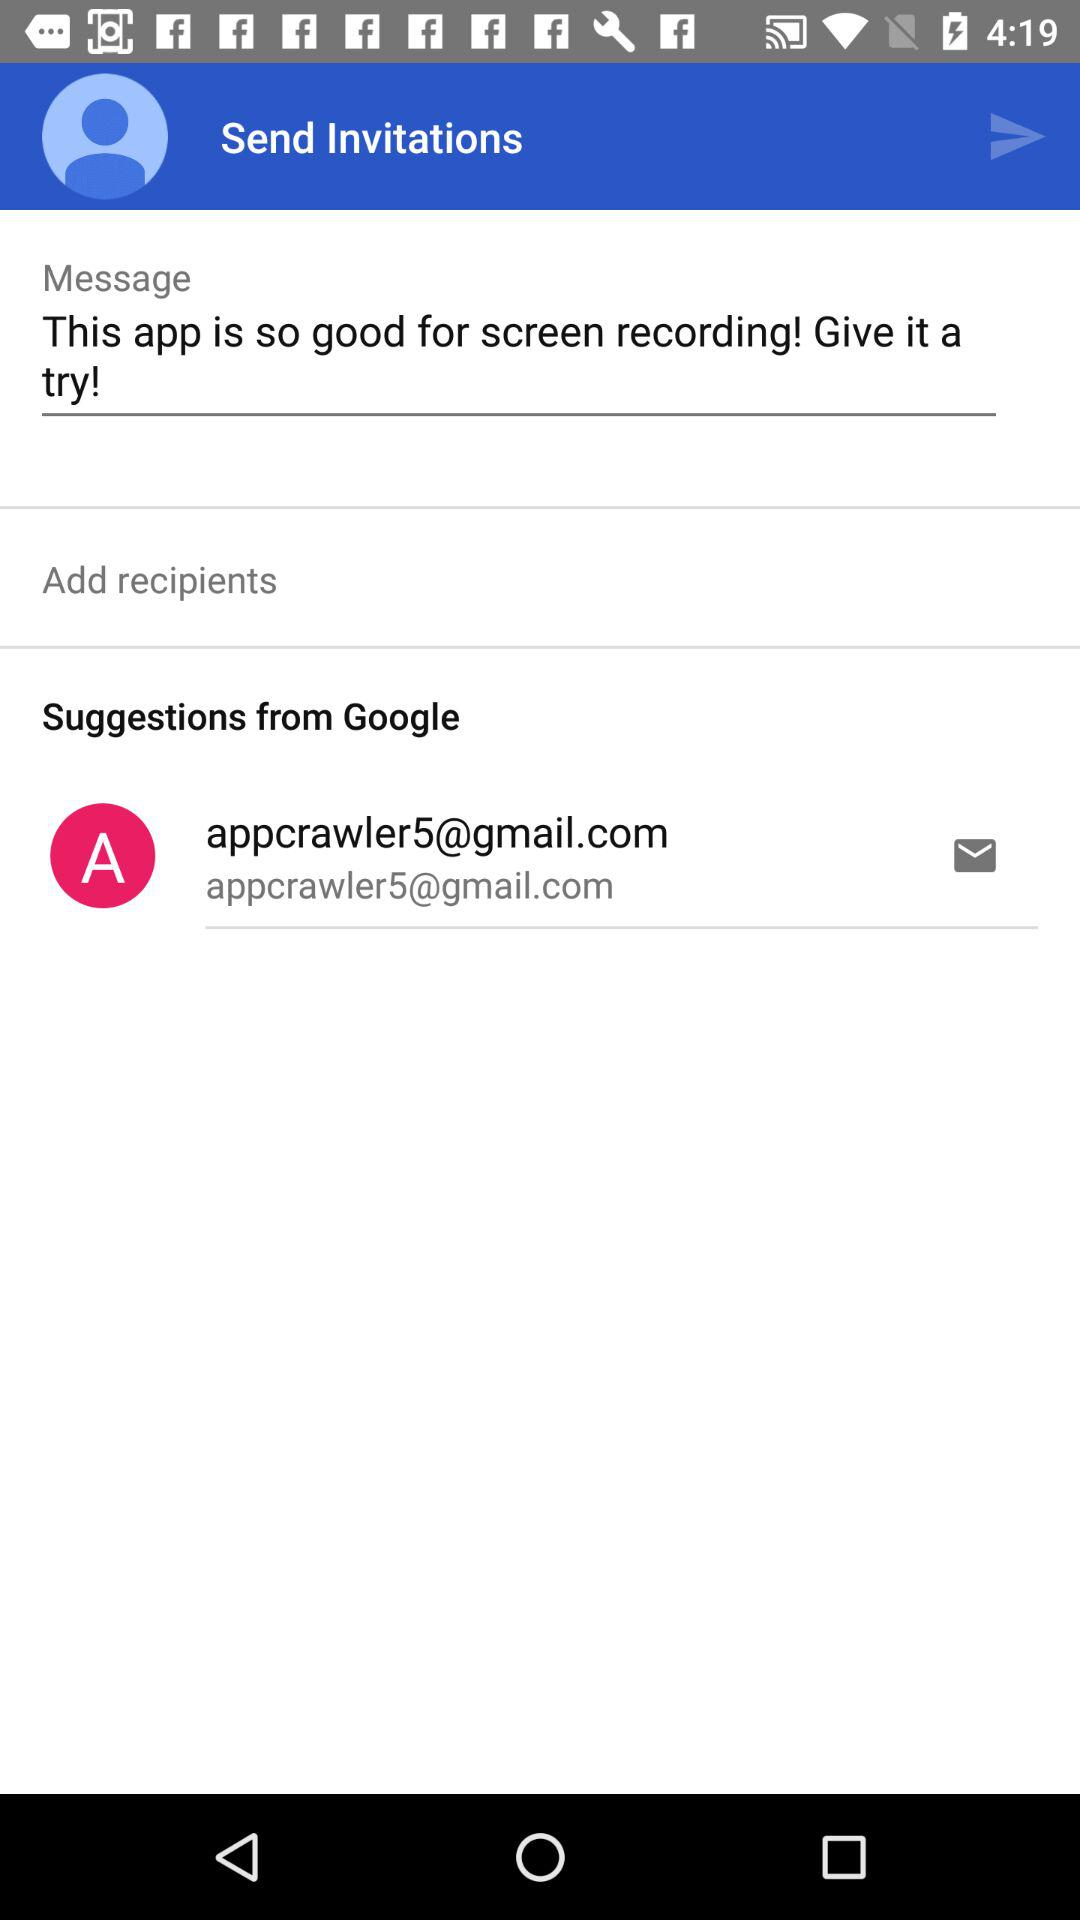How many more recipients are there than suggestions?
Answer the question using a single word or phrase. 1 